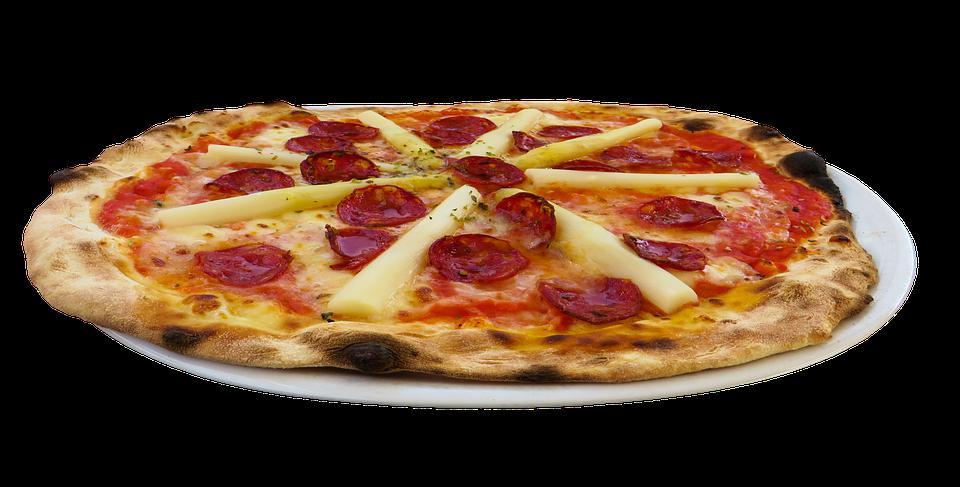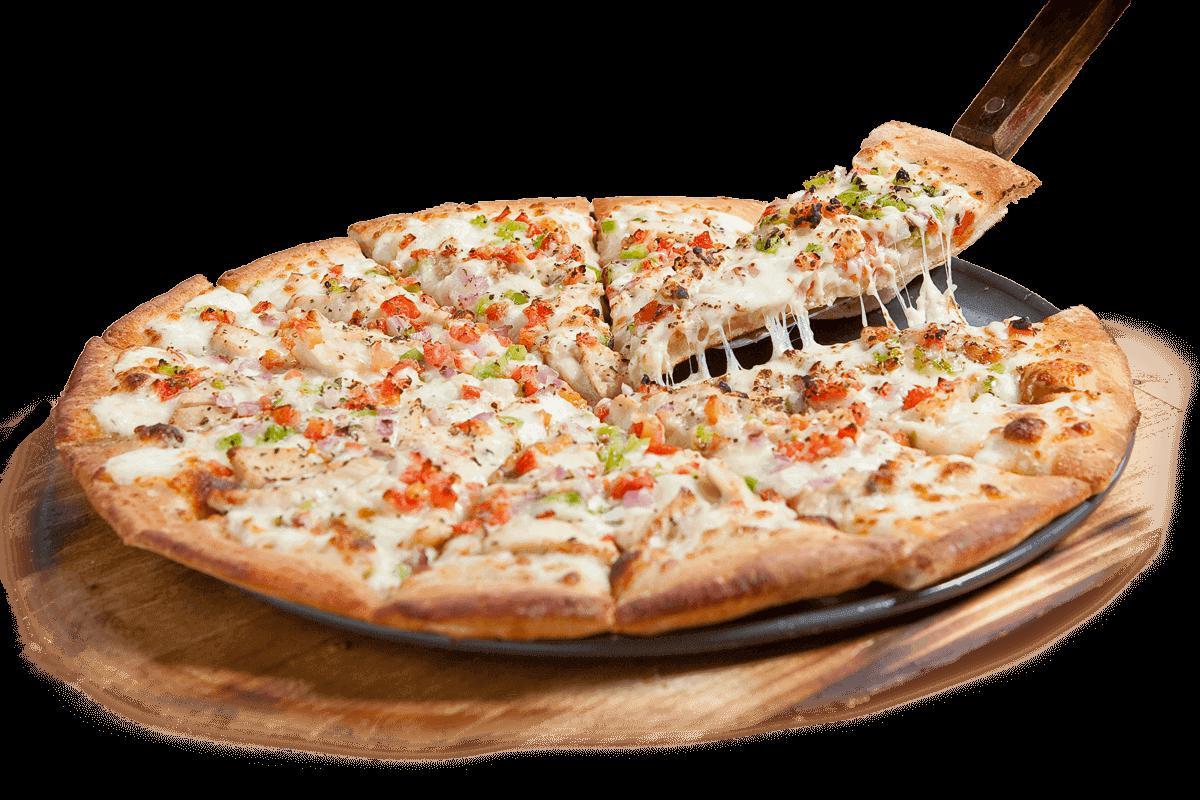The first image is the image on the left, the second image is the image on the right. Analyze the images presented: Is the assertion "A slice is being lifted off a pizza." valid? Answer yes or no. Yes. The first image is the image on the left, the second image is the image on the right. Given the left and right images, does the statement "A slice is being taken out of a pizza in the right image, with the cheese oozing down." hold true? Answer yes or no. Yes. 